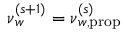<formula> <loc_0><loc_0><loc_500><loc_500>\boldsymbol \nu _ { w } ^ { ( s + 1 ) } = \boldsymbol \nu _ { w , p r o p } ^ { ( s ) }</formula> 